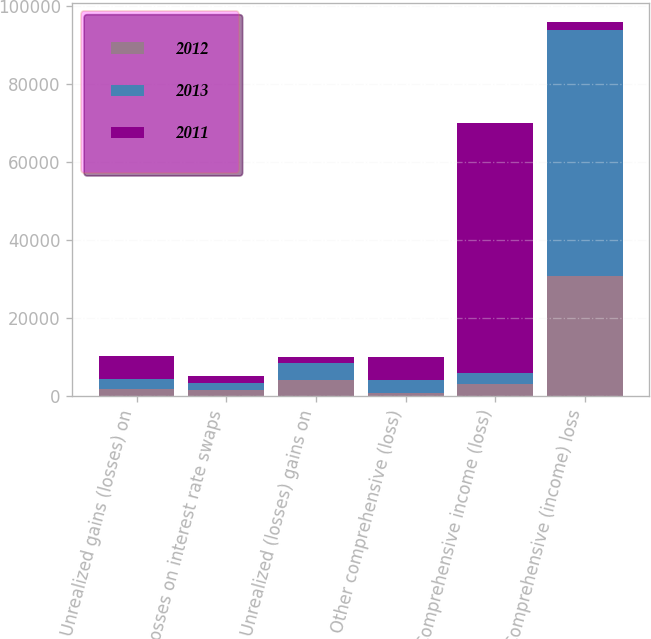Convert chart to OTSL. <chart><loc_0><loc_0><loc_500><loc_500><stacked_bar_chart><ecel><fcel>Unrealized gains (losses) on<fcel>Losses on interest rate swaps<fcel>Unrealized (losses) gains on<fcel>Other comprehensive (loss)<fcel>Comprehensive income (loss)<fcel>Comprehensive (income) loss<nl><fcel>2012<fcel>1734<fcel>1678<fcel>4188<fcel>776<fcel>3007<fcel>30819<nl><fcel>2013<fcel>2581<fcel>1673<fcel>4341<fcel>3433<fcel>3007<fcel>63020<nl><fcel>2011<fcel>5885<fcel>1667<fcel>1509<fcel>5727<fcel>63891<fcel>2020<nl></chart> 